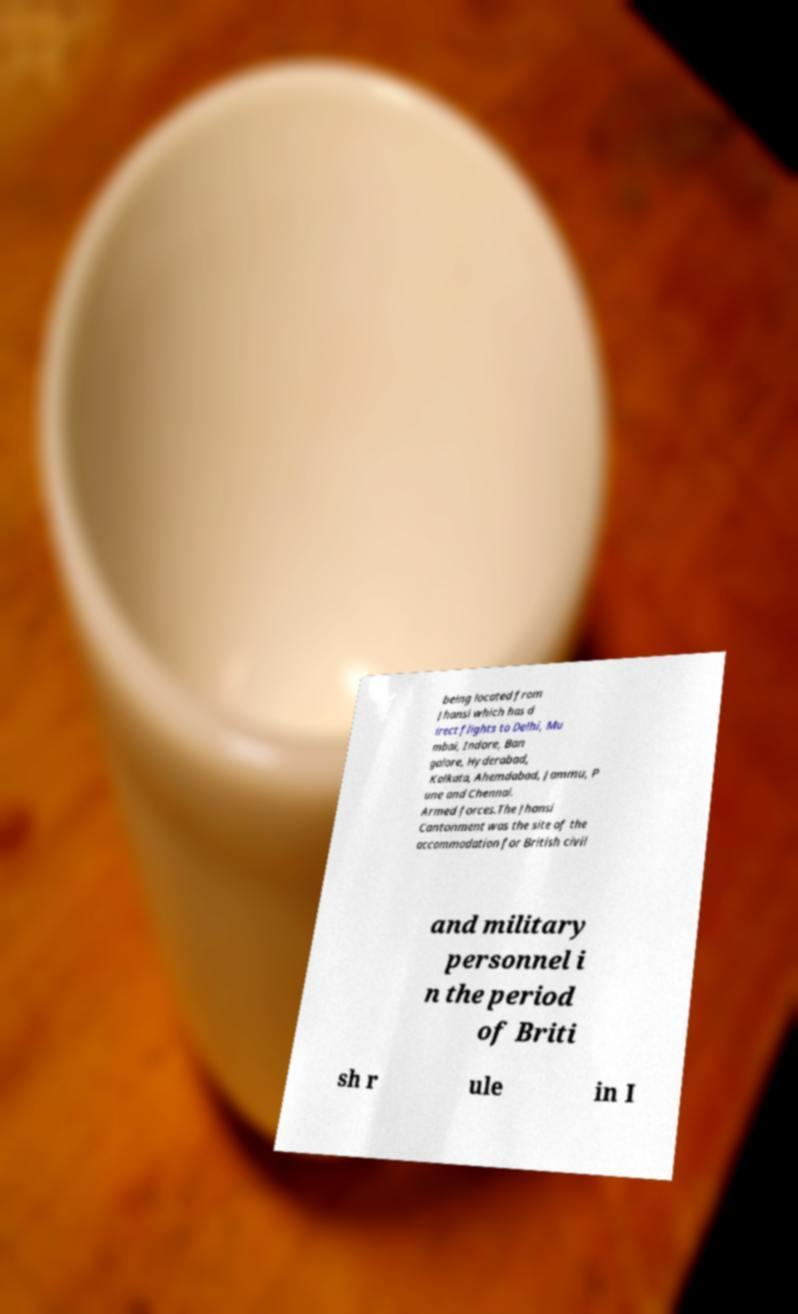Can you accurately transcribe the text from the provided image for me? being located from Jhansi which has d irect flights to Delhi, Mu mbai, Indore, Ban galore, Hyderabad, Kolkata, Ahemdabad, Jammu, P une and Chennai. Armed forces.The Jhansi Cantonment was the site of the accommodation for British civil and military personnel i n the period of Briti sh r ule in I 